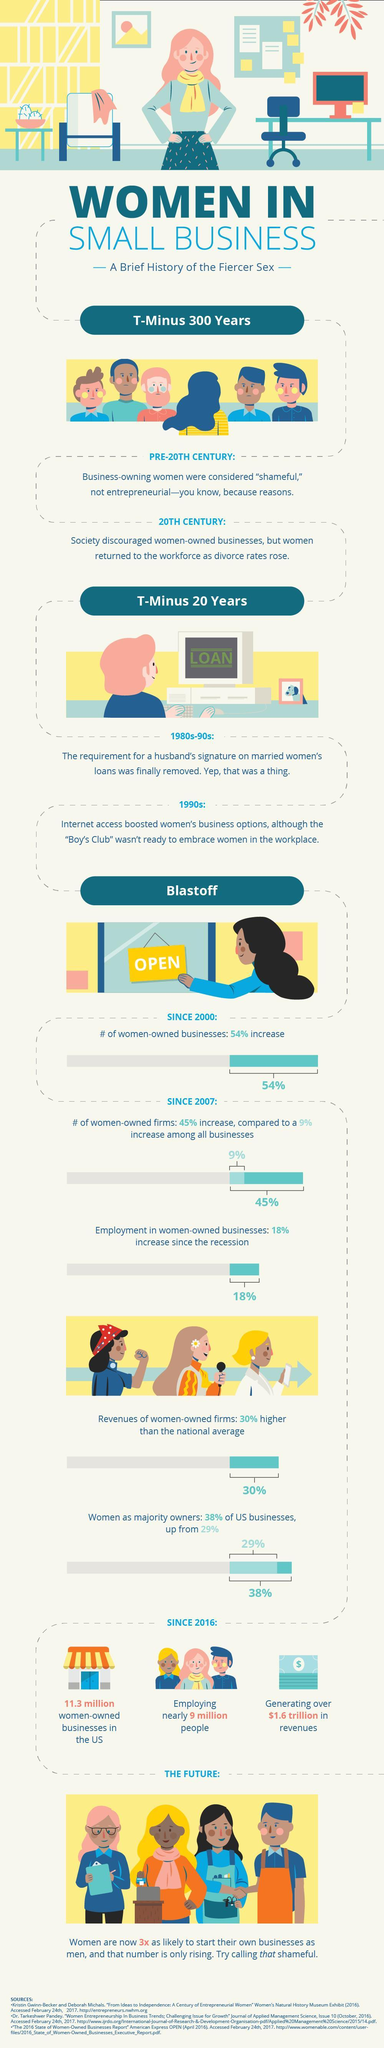What was the increase in women owned business after June 2009?
Answer the question with a short phrase. 18% 